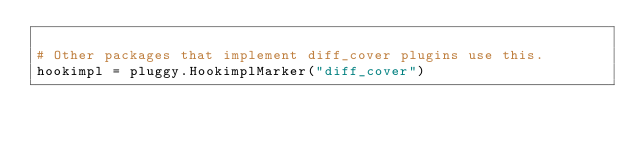Convert code to text. <code><loc_0><loc_0><loc_500><loc_500><_Python_>
# Other packages that implement diff_cover plugins use this.
hookimpl = pluggy.HookimplMarker("diff_cover")
</code> 